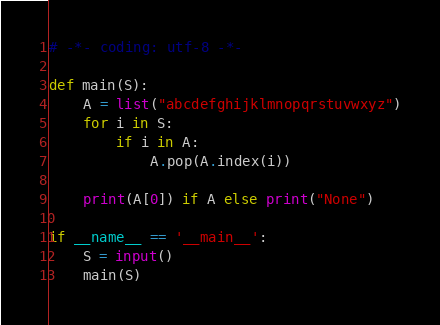Convert code to text. <code><loc_0><loc_0><loc_500><loc_500><_Python_># -*- coding: utf-8 -*-

def main(S):
    A = list("abcdefghijklmnopqrstuvwxyz")
    for i in S:
        if i in A:
            A.pop(A.index(i))

    print(A[0]) if A else print("None")
    
if __name__ == '__main__':
    S = input()
    main(S)</code> 